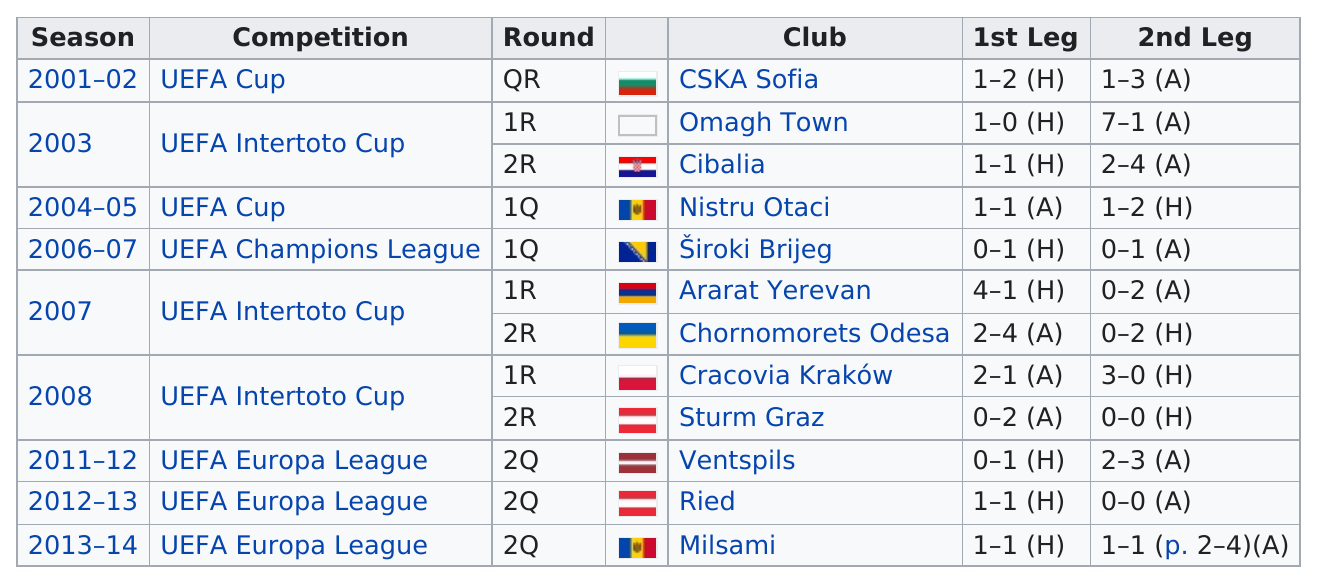Specify some key components in this picture. FC Shakhtyor Salihorsk has played a total of 9 seasons in European competition. In total, 12 clubs were played against. There are 7 ties in total. Ventspils is competing against Ried and Milsami in the same competition. FC Shakhtyor Salihorsk has played in the UEFA Europa League competition three times. 